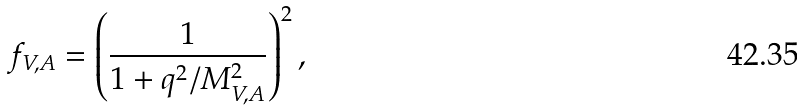Convert formula to latex. <formula><loc_0><loc_0><loc_500><loc_500>f _ { V , A } = \left ( \frac { 1 } { 1 + q ^ { 2 } / M _ { V , A } ^ { 2 } } \right ) ^ { 2 } ,</formula> 